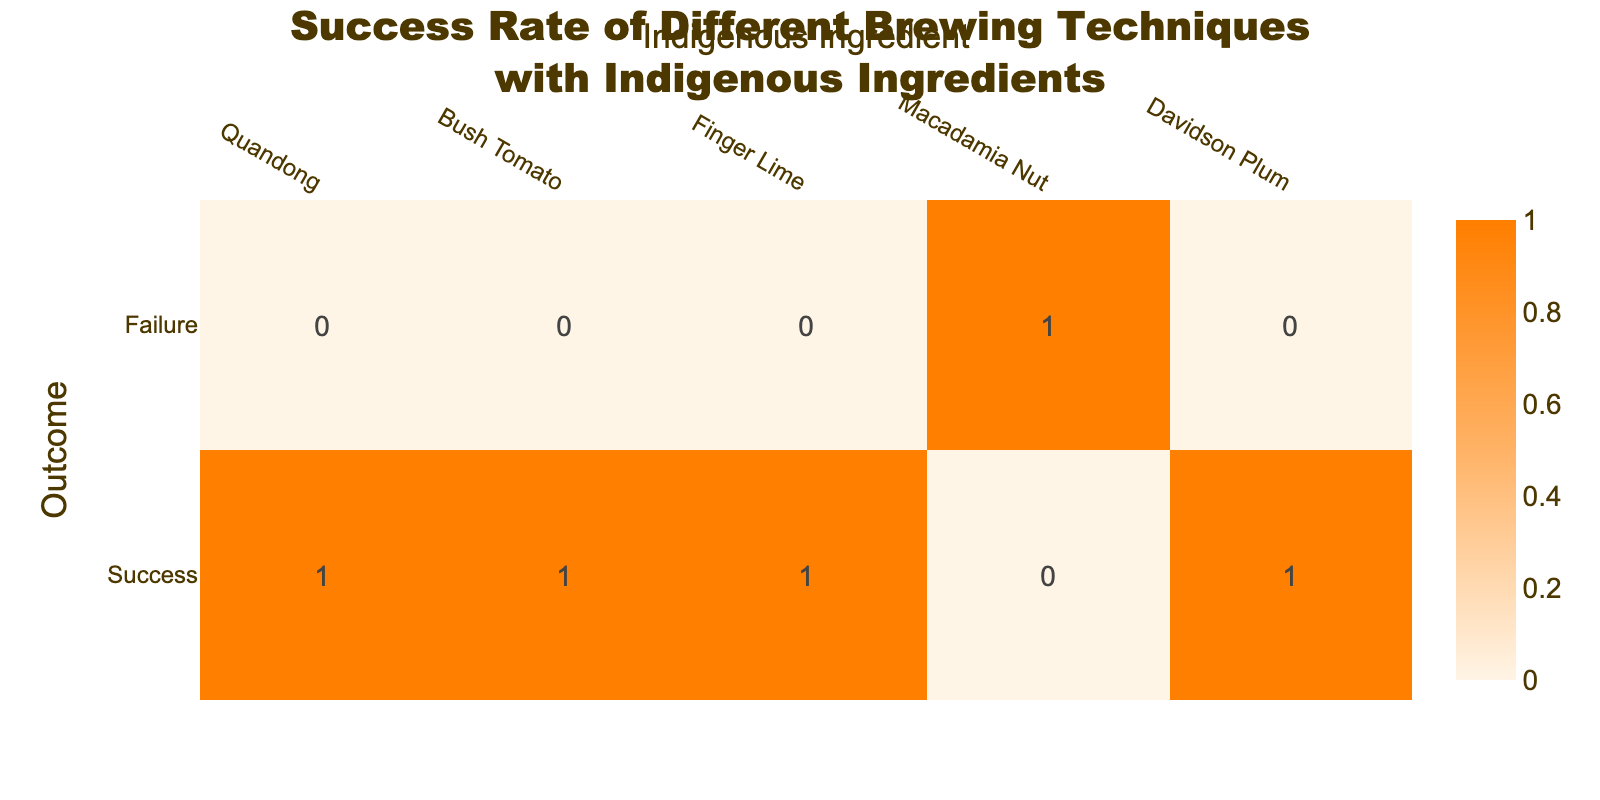What is the success rate for the Cold Brewing technique with Quandong? The success for Cold Brewing with Quandong is 1, and there are no failures (0). The success rate is simply the number of successes divided by the total attempts (success + failure), which is 1/(1 + 0) = 1.
Answer: 1 How many brewing techniques resulted in success using indigenous ingredients? There are 5 rows total in the table. Out of these, there are 4 techniques listed with a success value of 1. Thus, the total number of techniques that resulted in success is 4.
Answer: 4 Is there any brewing technique using indigenous ingredients that has a failure rate? The table shows that Spontaneous Fermentation using Macadamia Nut has a failure value of 1. Therefore, there is at least one technique with a failure rate.
Answer: Yes What is the total number of failures for the techniques listed? When examining the table, we see that there is only one instance of failure, which belongs to Spontaneous Fermentation with a failure value of 1. Therefore, the total number of failures across the techniques is 1.
Answer: 1 Which indigenous ingredient corresponds with the highest success rate among the listed techniques? By checking each row, we see that all except one technique have a success rate of 1. Thus, the indigenous ingredients linked with the highest success rate (which is 100%) are Quandong, Bush Tomato, Finger Lime, and Davidson Plum.
Answer: Quandong, Bush Tomato, Finger Lime, and Davidson Plum If we consider only successful brewing techniques, what is the average success rate? All successful techniques listed have a success value of 1. Therefore, the average success rate can be calculated as (1 + 1 + 1 + 1) / 4 = 1. Since all successes equal 1, the average is also 1.
Answer: 1 Which brewing technique had the least success and what was the corresponding ingredient? Looking at the table, we see that Spontaneous Fermentation with Macadamia Nut was the only technique that resulted in a failure (0 successes). Therefore, this is the technique with the least success.
Answer: Spontaneous Fermentation, Macadamia Nut If we only consider successful techniques, how many are there using Native Yeast? Only one technique listed involves Native Yeast, which is Fermentation with Native Yeast, and it has a success of 1. Thus, there is 1 successful technique using Native Yeast.
Answer: 1 